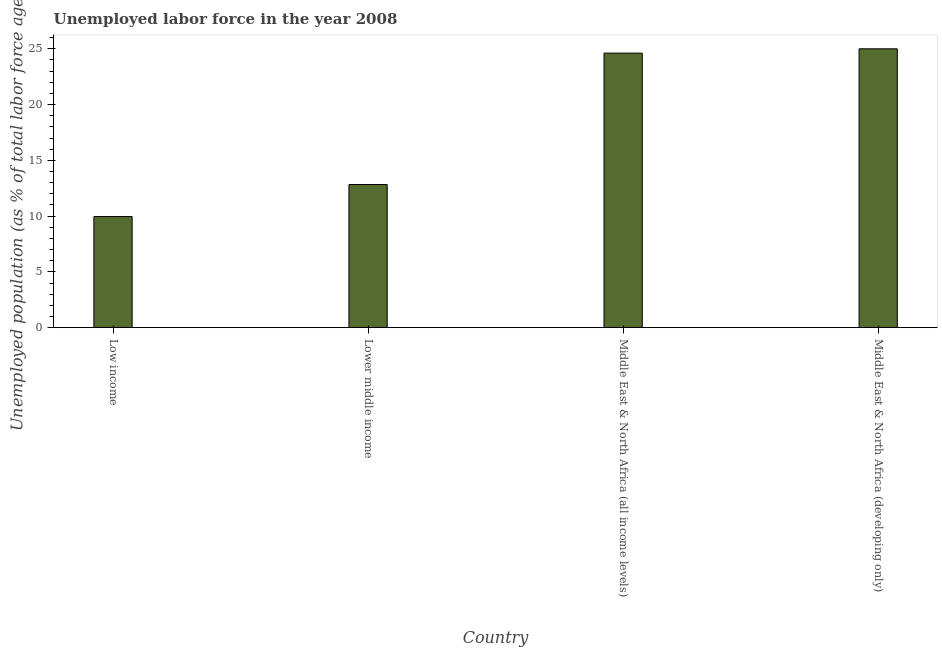Does the graph contain any zero values?
Your answer should be very brief. No. What is the title of the graph?
Provide a succinct answer. Unemployed labor force in the year 2008. What is the label or title of the X-axis?
Provide a short and direct response. Country. What is the label or title of the Y-axis?
Offer a very short reply. Unemployed population (as % of total labor force ages 15-24). What is the total unemployed youth population in Middle East & North Africa (all income levels)?
Make the answer very short. 24.62. Across all countries, what is the maximum total unemployed youth population?
Give a very brief answer. 25. Across all countries, what is the minimum total unemployed youth population?
Give a very brief answer. 9.96. In which country was the total unemployed youth population maximum?
Offer a terse response. Middle East & North Africa (developing only). What is the sum of the total unemployed youth population?
Make the answer very short. 72.41. What is the difference between the total unemployed youth population in Low income and Middle East & North Africa (all income levels)?
Offer a terse response. -14.65. What is the average total unemployed youth population per country?
Offer a terse response. 18.1. What is the median total unemployed youth population?
Ensure brevity in your answer.  18.72. In how many countries, is the total unemployed youth population greater than 23 %?
Your answer should be very brief. 2. What is the ratio of the total unemployed youth population in Lower middle income to that in Middle East & North Africa (all income levels)?
Offer a very short reply. 0.52. What is the difference between the highest and the second highest total unemployed youth population?
Give a very brief answer. 0.39. What is the difference between the highest and the lowest total unemployed youth population?
Offer a very short reply. 15.04. In how many countries, is the total unemployed youth population greater than the average total unemployed youth population taken over all countries?
Your answer should be very brief. 2. How many bars are there?
Keep it short and to the point. 4. How many countries are there in the graph?
Ensure brevity in your answer.  4. What is the difference between two consecutive major ticks on the Y-axis?
Offer a terse response. 5. What is the Unemployed population (as % of total labor force ages 15-24) in Low income?
Offer a terse response. 9.96. What is the Unemployed population (as % of total labor force ages 15-24) in Lower middle income?
Your response must be concise. 12.83. What is the Unemployed population (as % of total labor force ages 15-24) in Middle East & North Africa (all income levels)?
Provide a short and direct response. 24.62. What is the Unemployed population (as % of total labor force ages 15-24) in Middle East & North Africa (developing only)?
Your answer should be compact. 25. What is the difference between the Unemployed population (as % of total labor force ages 15-24) in Low income and Lower middle income?
Your answer should be very brief. -2.87. What is the difference between the Unemployed population (as % of total labor force ages 15-24) in Low income and Middle East & North Africa (all income levels)?
Offer a very short reply. -14.65. What is the difference between the Unemployed population (as % of total labor force ages 15-24) in Low income and Middle East & North Africa (developing only)?
Offer a terse response. -15.04. What is the difference between the Unemployed population (as % of total labor force ages 15-24) in Lower middle income and Middle East & North Africa (all income levels)?
Ensure brevity in your answer.  -11.78. What is the difference between the Unemployed population (as % of total labor force ages 15-24) in Lower middle income and Middle East & North Africa (developing only)?
Provide a short and direct response. -12.17. What is the difference between the Unemployed population (as % of total labor force ages 15-24) in Middle East & North Africa (all income levels) and Middle East & North Africa (developing only)?
Ensure brevity in your answer.  -0.39. What is the ratio of the Unemployed population (as % of total labor force ages 15-24) in Low income to that in Lower middle income?
Ensure brevity in your answer.  0.78. What is the ratio of the Unemployed population (as % of total labor force ages 15-24) in Low income to that in Middle East & North Africa (all income levels)?
Offer a terse response. 0.41. What is the ratio of the Unemployed population (as % of total labor force ages 15-24) in Low income to that in Middle East & North Africa (developing only)?
Provide a short and direct response. 0.4. What is the ratio of the Unemployed population (as % of total labor force ages 15-24) in Lower middle income to that in Middle East & North Africa (all income levels)?
Your response must be concise. 0.52. What is the ratio of the Unemployed population (as % of total labor force ages 15-24) in Lower middle income to that in Middle East & North Africa (developing only)?
Ensure brevity in your answer.  0.51. What is the ratio of the Unemployed population (as % of total labor force ages 15-24) in Middle East & North Africa (all income levels) to that in Middle East & North Africa (developing only)?
Your answer should be compact. 0.98. 